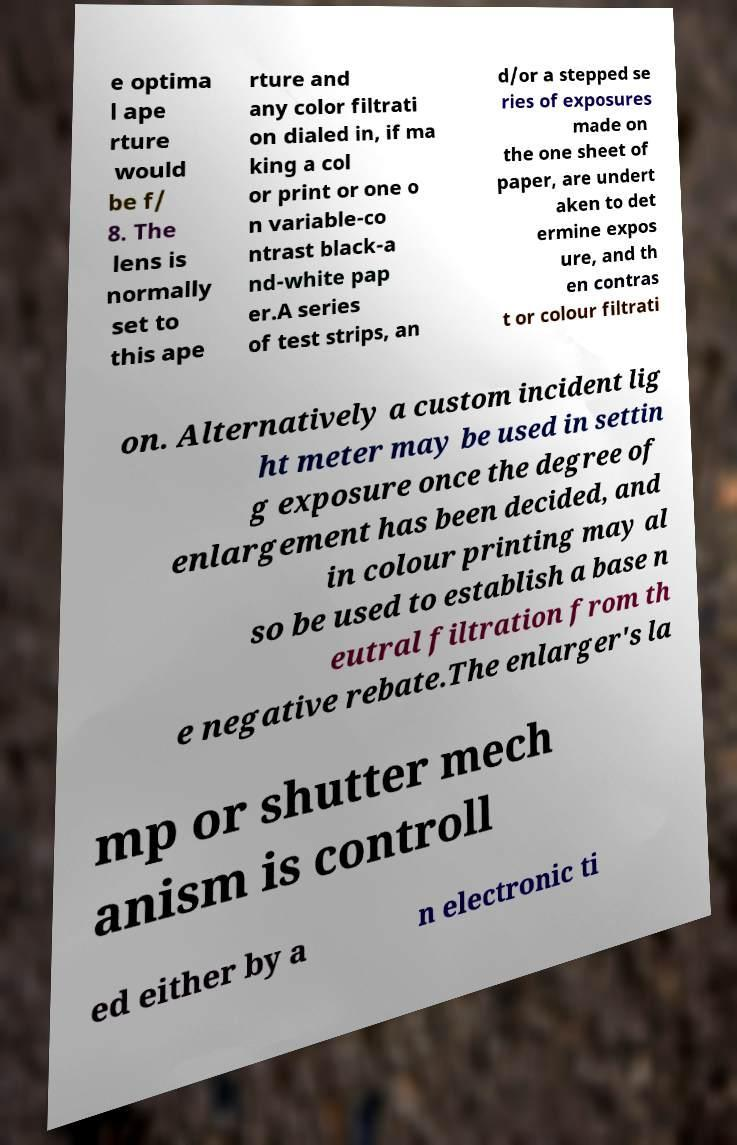I need the written content from this picture converted into text. Can you do that? e optima l ape rture would be f/ 8. The lens is normally set to this ape rture and any color filtrati on dialed in, if ma king a col or print or one o n variable-co ntrast black-a nd-white pap er.A series of test strips, an d/or a stepped se ries of exposures made on the one sheet of paper, are undert aken to det ermine expos ure, and th en contras t or colour filtrati on. Alternatively a custom incident lig ht meter may be used in settin g exposure once the degree of enlargement has been decided, and in colour printing may al so be used to establish a base n eutral filtration from th e negative rebate.The enlarger's la mp or shutter mech anism is controll ed either by a n electronic ti 